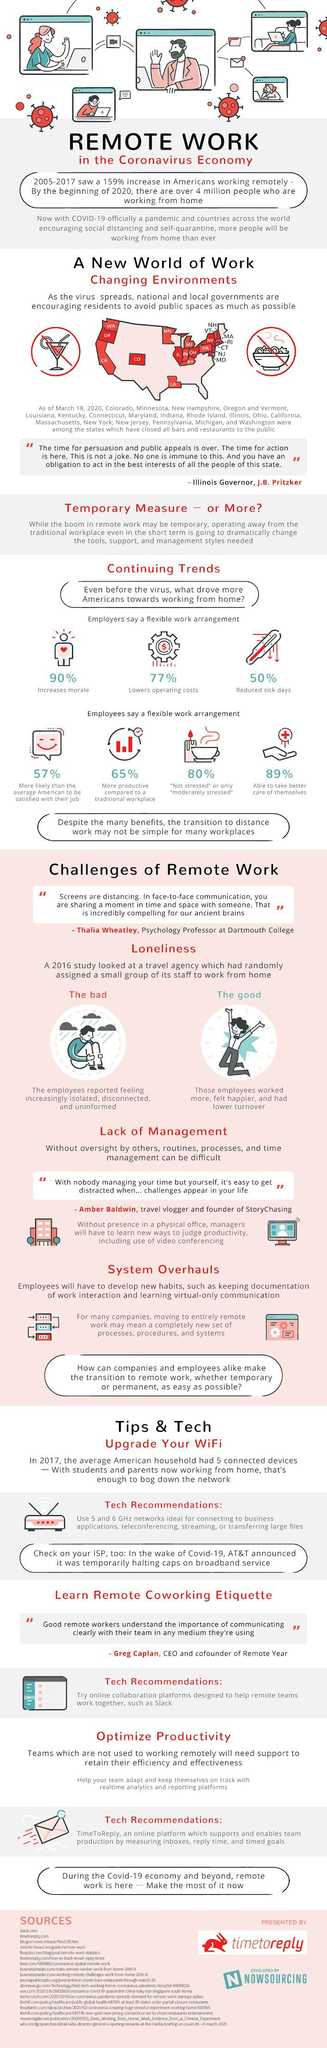What are the 3 important tips & tech
Answer the question with a short phrase. Upgrade your WiFi, Learn Remote Coworking Etiquette, Optimize Productivity In continuing trends, what does the thermometer indicate 50% reduced sick days How does the flexible work arrangements help employers? 90% Increases morale, 77% lowers operating costs, 50% reduced sick days How does the flexible work arrangements help 80% employees? "Not stressed" or only "moderately stressed" What was the bad impact of work from home the employees reported feeling increasingly isolated, disconnected, and uninformed 